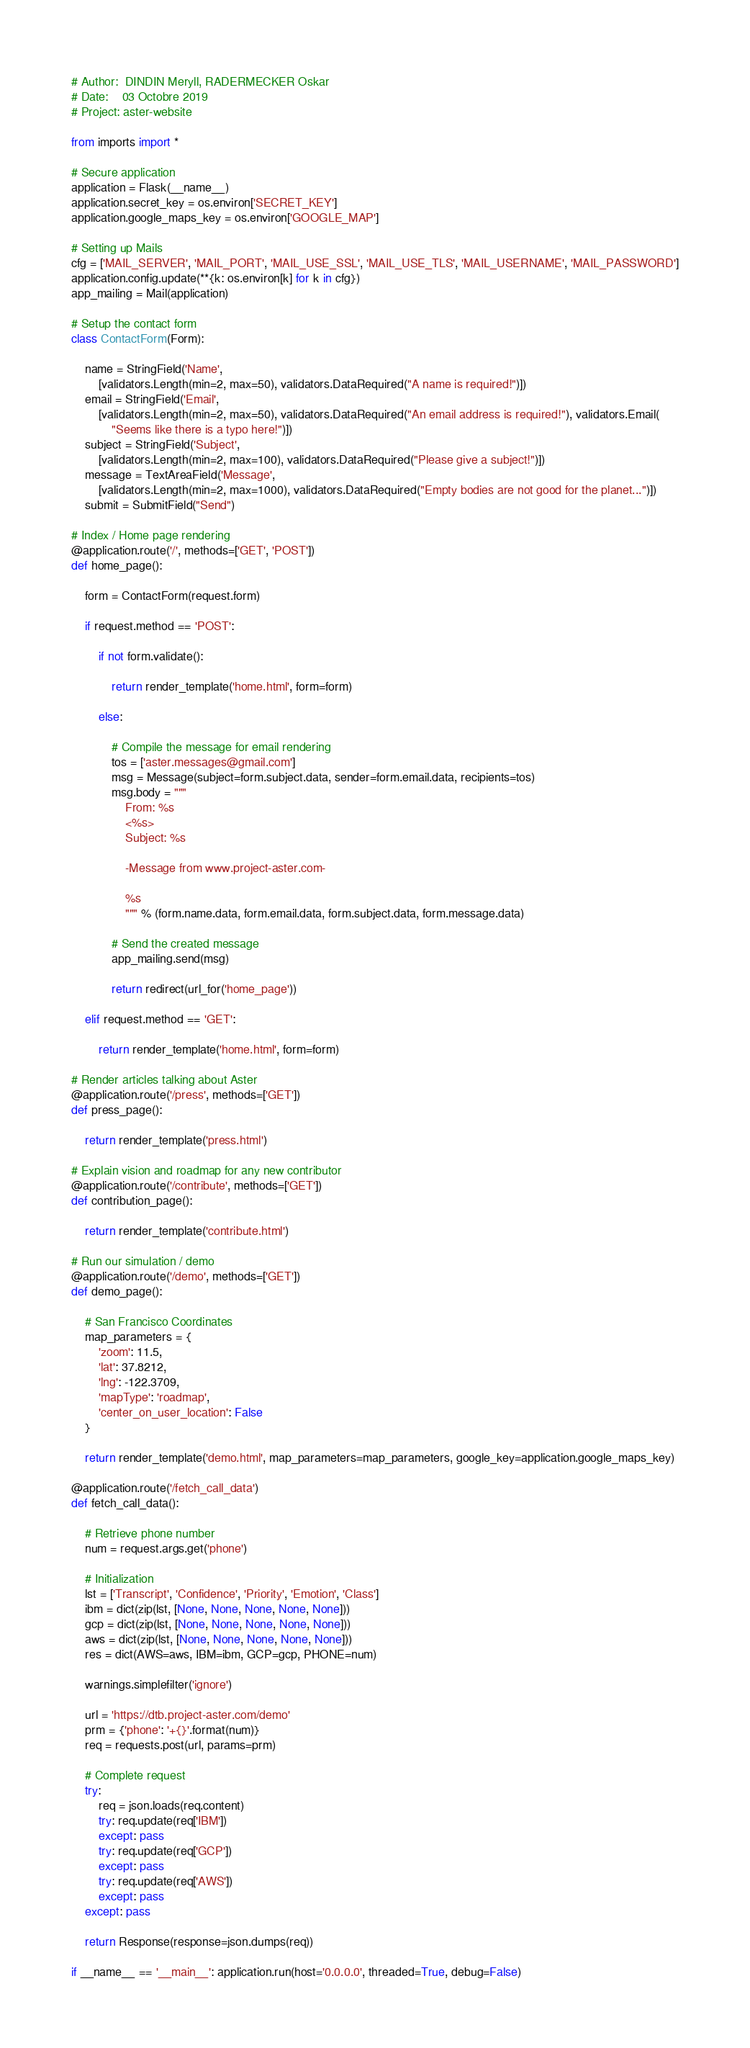Convert code to text. <code><loc_0><loc_0><loc_500><loc_500><_Python_># Author:  DINDIN Meryll, RADERMECKER Oskar
# Date:    03 Octobre 2019
# Project: aster-website

from imports import *

# Secure application
application = Flask(__name__)
application.secret_key = os.environ['SECRET_KEY']
application.google_maps_key = os.environ['GOOGLE_MAP']

# Setting up Mails
cfg = ['MAIL_SERVER', 'MAIL_PORT', 'MAIL_USE_SSL', 'MAIL_USE_TLS', 'MAIL_USERNAME', 'MAIL_PASSWORD']
application.config.update(**{k: os.environ[k] for k in cfg})
app_mailing = Mail(application)

# Setup the contact form
class ContactForm(Form):

    name = StringField('Name', 
        [validators.Length(min=2, max=50), validators.DataRequired("A name is required!")])
    email = StringField('Email', 
        [validators.Length(min=2, max=50), validators.DataRequired("An email address is required!"), validators.Email(
            "Seems like there is a typo here!")])
    subject = StringField('Subject', 
        [validators.Length(min=2, max=100), validators.DataRequired("Please give a subject!")])
    message = TextAreaField('Message', 
        [validators.Length(min=2, max=1000), validators.DataRequired("Empty bodies are not good for the planet...")])
    submit = SubmitField("Send")

# Index / Home page rendering
@application.route('/', methods=['GET', 'POST'])
def home_page():

    form = ContactForm(request.form)

    if request.method == 'POST':

        if not form.validate():

            return render_template('home.html', form=form)

        else:

            # Compile the message for email rendering
            tos = ['aster.messages@gmail.com']
            msg = Message(subject=form.subject.data, sender=form.email.data, recipients=tos)
            msg.body = """
                From: %s 
                <%s>
                Subject: %s

                -Message from www.project-aster.com-

                %s
                """ % (form.name.data, form.email.data, form.subject.data, form.message.data)

            # Send the created message
            app_mailing.send(msg)

            return redirect(url_for('home_page'))

    elif request.method == 'GET':

        return render_template('home.html', form=form)

# Render articles talking about Aster
@application.route('/press', methods=['GET'])
def press_page():

    return render_template('press.html')

# Explain vision and roadmap for any new contributor
@application.route('/contribute', methods=['GET'])
def contribution_page():

    return render_template('contribute.html')

# Run our simulation / demo
@application.route('/demo', methods=['GET'])
def demo_page():

    # San Francisco Coordinates
    map_parameters = {
        'zoom': 11.5,
        'lat': 37.8212,  
        'lng': -122.3709,
        'mapType': 'roadmap',
        'center_on_user_location': False
    }

    return render_template('demo.html', map_parameters=map_parameters, google_key=application.google_maps_key)

@application.route('/fetch_call_data')
def fetch_call_data():

    # Retrieve phone number
    num = request.args.get('phone')

    # Initialization
    lst = ['Transcript', 'Confidence', 'Priority', 'Emotion', 'Class']
    ibm = dict(zip(lst, [None, None, None, None, None]))
    gcp = dict(zip(lst, [None, None, None, None, None]))
    aws = dict(zip(lst, [None, None, None, None, None]))
    res = dict(AWS=aws, IBM=ibm, GCP=gcp, PHONE=num)

    warnings.simplefilter('ignore')

    url = 'https://dtb.project-aster.com/demo'
    prm = {'phone': '+{}'.format(num)}
    req = requests.post(url, params=prm)

    # Complete request
    try:
        req = json.loads(req.content)
        try: req.update(req['IBM'])
        except: pass
        try: req.update(req['GCP'])
        except: pass
        try: req.update(req['AWS'])
        except: pass
    except: pass

    return Response(response=json.dumps(req))

if __name__ == '__main__': application.run(host='0.0.0.0', threaded=True, debug=False)
</code> 